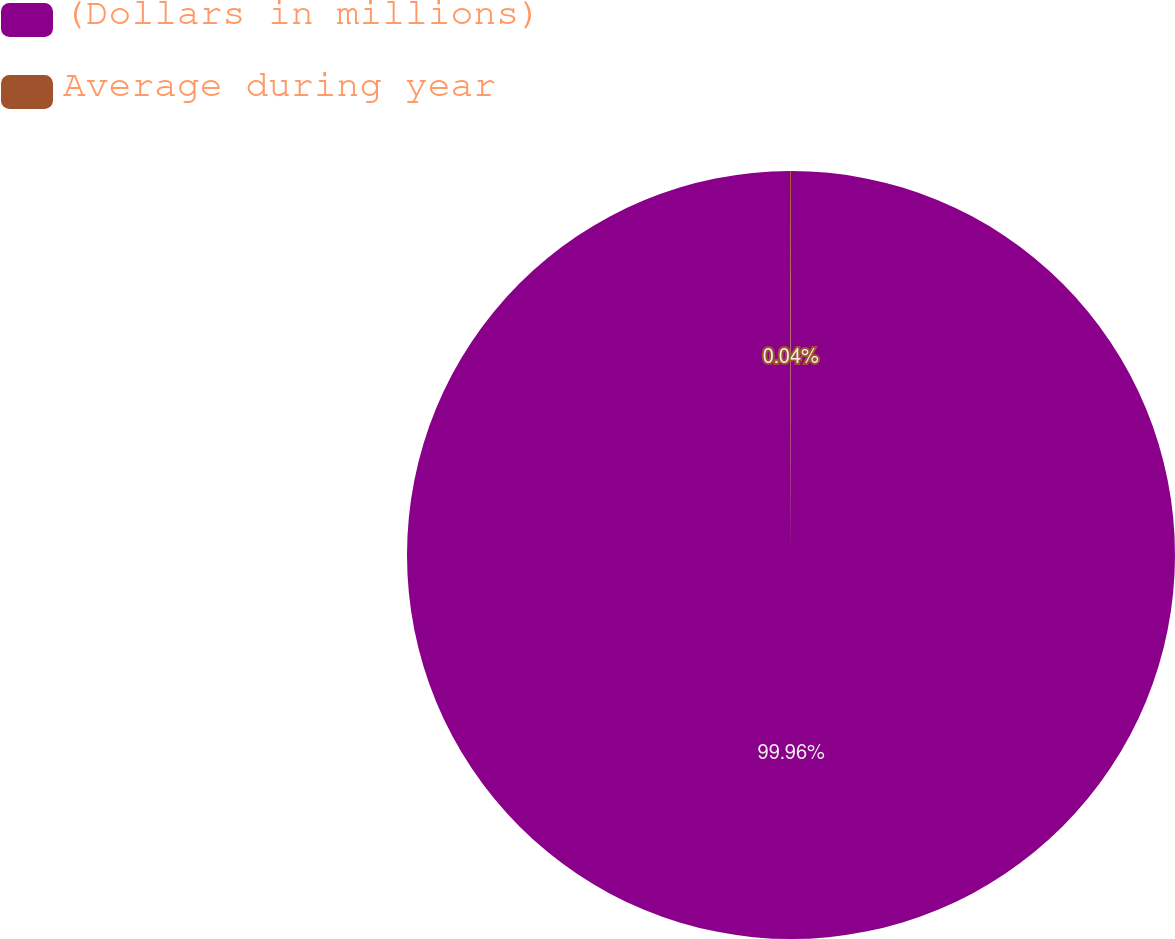Convert chart to OTSL. <chart><loc_0><loc_0><loc_500><loc_500><pie_chart><fcel>(Dollars in millions)<fcel>Average during year<nl><fcel>99.96%<fcel>0.04%<nl></chart> 